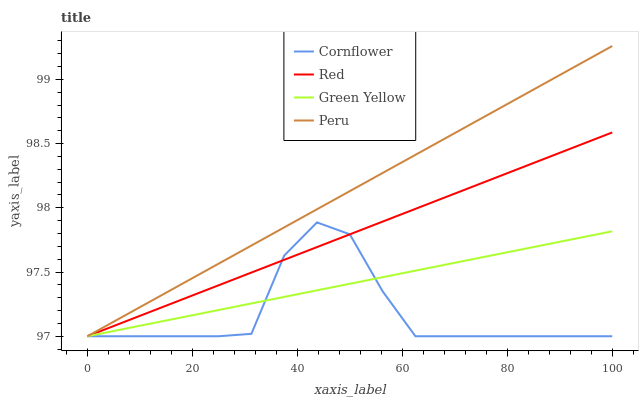Does Cornflower have the minimum area under the curve?
Answer yes or no. Yes. Does Peru have the maximum area under the curve?
Answer yes or no. Yes. Does Green Yellow have the minimum area under the curve?
Answer yes or no. No. Does Green Yellow have the maximum area under the curve?
Answer yes or no. No. Is Peru the smoothest?
Answer yes or no. Yes. Is Cornflower the roughest?
Answer yes or no. Yes. Is Green Yellow the smoothest?
Answer yes or no. No. Is Green Yellow the roughest?
Answer yes or no. No. Does Cornflower have the lowest value?
Answer yes or no. Yes. Does Peru have the highest value?
Answer yes or no. Yes. Does Green Yellow have the highest value?
Answer yes or no. No. Does Green Yellow intersect Cornflower?
Answer yes or no. Yes. Is Green Yellow less than Cornflower?
Answer yes or no. No. Is Green Yellow greater than Cornflower?
Answer yes or no. No. 